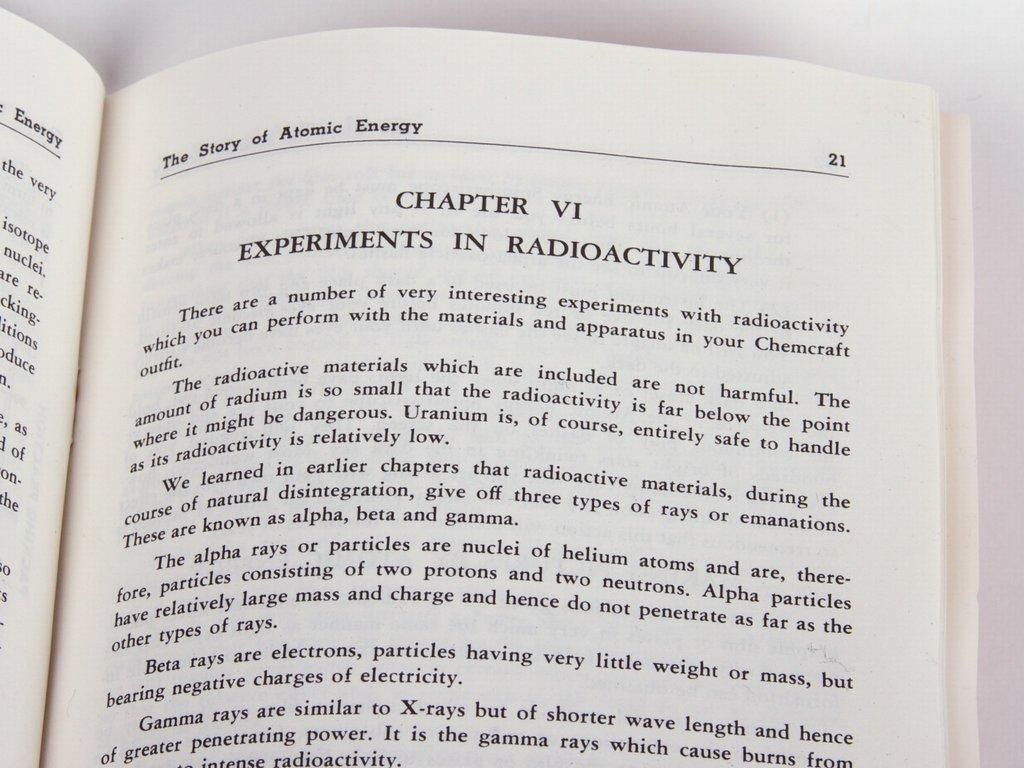<image>
Relay a brief, clear account of the picture shown. The Story of Atomic Energy is opened up to Chapter VI 